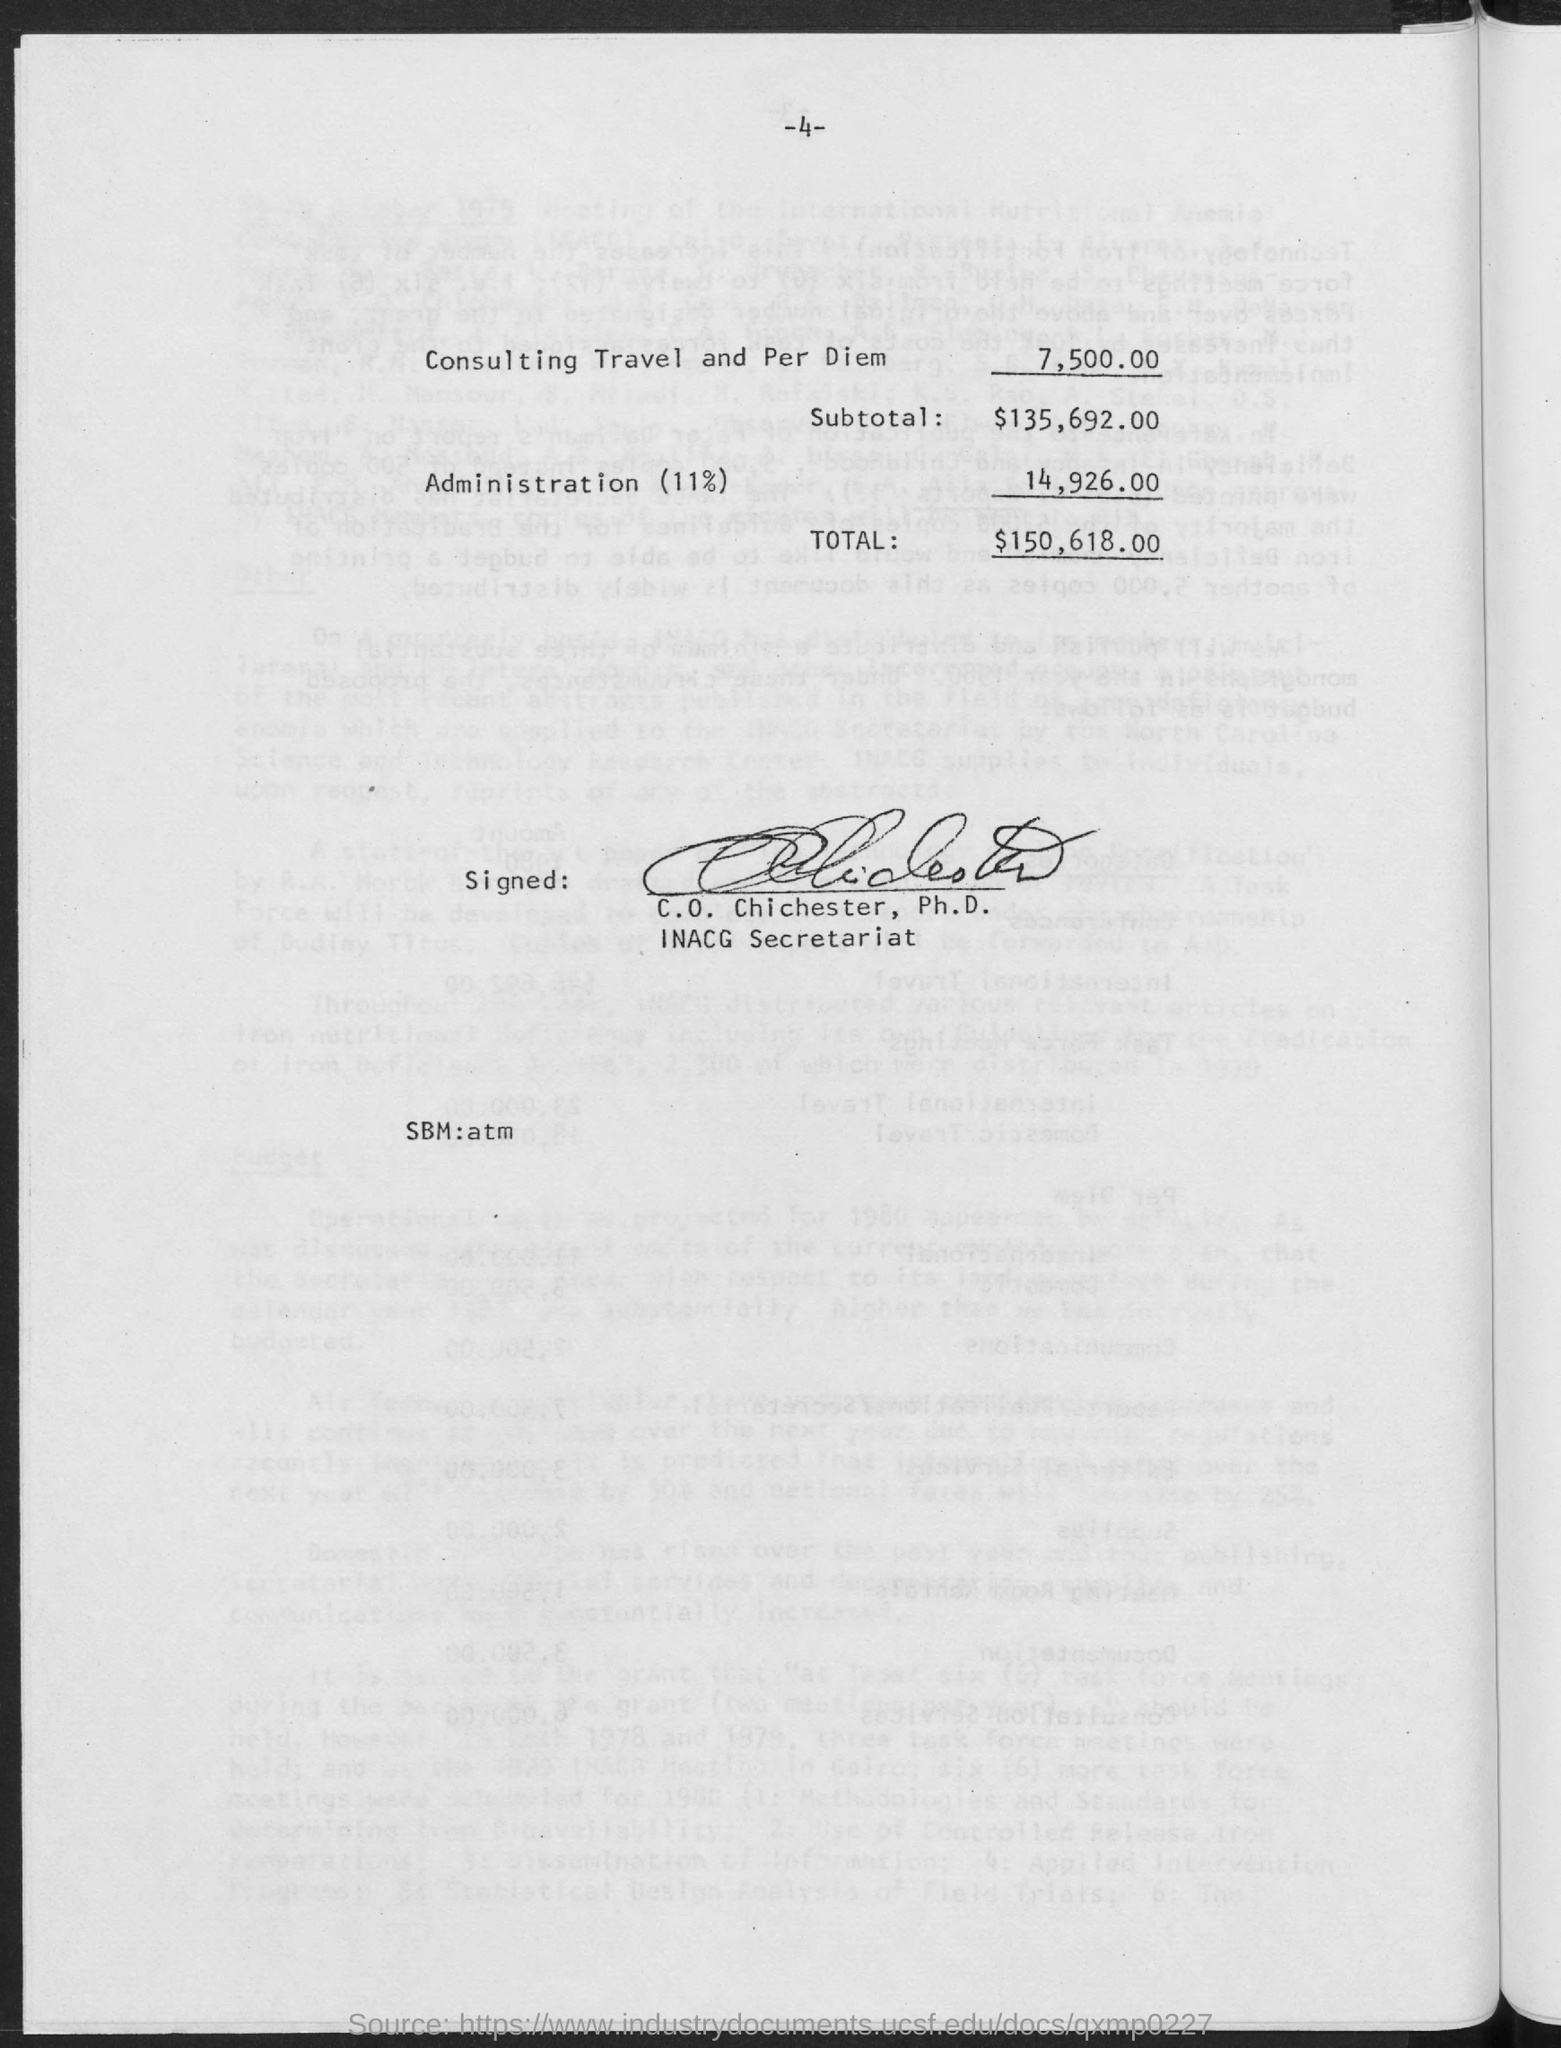How much is Consulting Travel and Per Diem?
Your answer should be compact. 7,500.00. What is the subtotal?
Your answer should be very brief. $135,692.00. How much is administration (11%)?
Your response must be concise. 14,926.00. What is the Total?
Your response must be concise. $150,618.00. Who is it signed by?
Give a very brief answer. C. O. Chichester, Ph.D. 